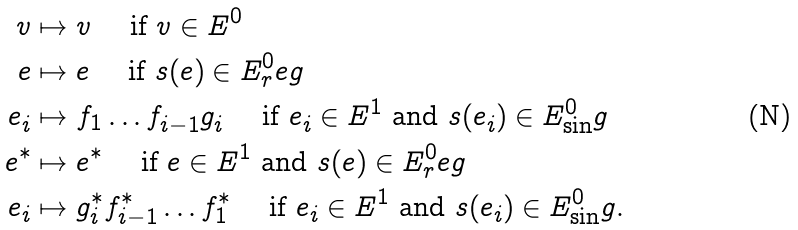<formula> <loc_0><loc_0><loc_500><loc_500>v & \mapsto v \quad \text { if $v \in E^{0}$ } \\ e & \mapsto e \quad \text { if $s(e) \in E^{0}_{r}eg$} \\ e _ { i } & \mapsto f _ { 1 } \dots f _ { i - 1 } g _ { i } \quad \text { if $e_{i} \in E^{1}$ and $s(e_{i}) \in E^{0}_{\sin}g$} \\ e ^ { * } & \mapsto e ^ { * } \quad \text { if $e \in E^{1}$ and $s(e) \in E^{0}_{r}eg$} \\ e _ { i } & \mapsto g _ { i } ^ { * } f _ { i - 1 } ^ { * } \dots f _ { 1 } ^ { * } \quad \text { if $e_{i} \in E^{1}$ and $s(e_{i}) \in E^{0}_{\sin}g$.}</formula> 